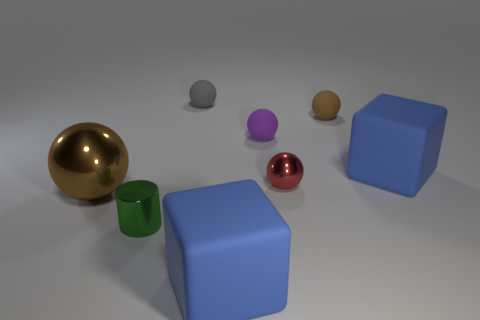Are there fewer matte spheres that are behind the small purple matte thing than spheres?
Provide a succinct answer. Yes. Does the brown rubber thing have the same shape as the purple thing?
Keep it short and to the point. Yes. The red ball that is made of the same material as the big brown object is what size?
Ensure brevity in your answer.  Small. Are there fewer green things than large brown blocks?
Offer a terse response. No. How many big objects are either brown rubber spheres or gray balls?
Your answer should be compact. 0. How many brown objects are on the right side of the small gray ball and in front of the purple rubber ball?
Offer a terse response. 0. Is the number of brown matte objects greater than the number of blue matte things?
Your answer should be compact. No. How many other things are the same shape as the tiny red thing?
Your answer should be very brief. 4. What is the thing that is behind the purple sphere and right of the tiny gray thing made of?
Offer a very short reply. Rubber. What is the size of the metallic cylinder?
Provide a short and direct response. Small. 